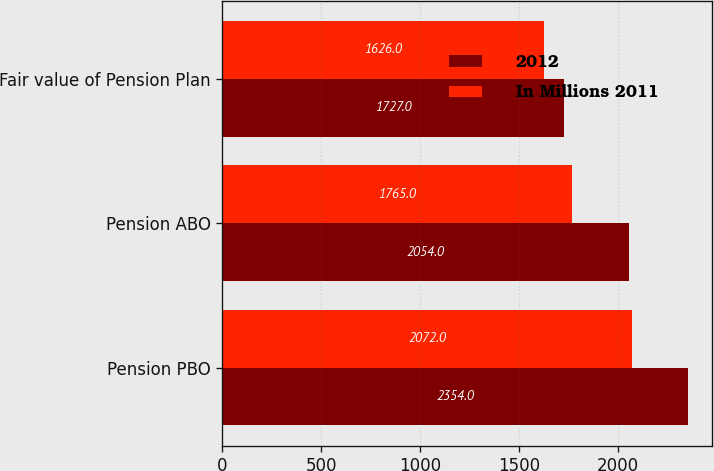<chart> <loc_0><loc_0><loc_500><loc_500><stacked_bar_chart><ecel><fcel>Pension PBO<fcel>Pension ABO<fcel>Fair value of Pension Plan<nl><fcel>2012<fcel>2354<fcel>2054<fcel>1727<nl><fcel>In Millions 2011<fcel>2072<fcel>1765<fcel>1626<nl></chart> 